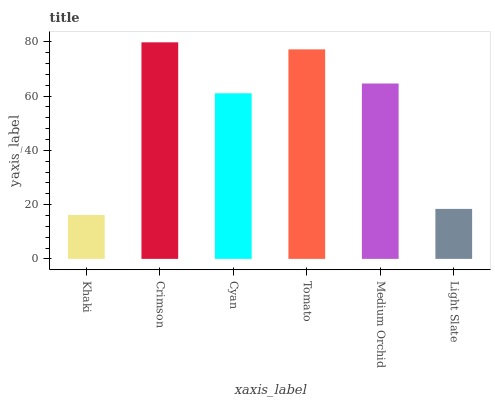Is Khaki the minimum?
Answer yes or no. Yes. Is Crimson the maximum?
Answer yes or no. Yes. Is Cyan the minimum?
Answer yes or no. No. Is Cyan the maximum?
Answer yes or no. No. Is Crimson greater than Cyan?
Answer yes or no. Yes. Is Cyan less than Crimson?
Answer yes or no. Yes. Is Cyan greater than Crimson?
Answer yes or no. No. Is Crimson less than Cyan?
Answer yes or no. No. Is Medium Orchid the high median?
Answer yes or no. Yes. Is Cyan the low median?
Answer yes or no. Yes. Is Khaki the high median?
Answer yes or no. No. Is Light Slate the low median?
Answer yes or no. No. 